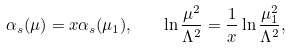Convert formula to latex. <formula><loc_0><loc_0><loc_500><loc_500>\alpha _ { s } ( \mu ) = x \alpha _ { s } ( \mu _ { 1 } ) , \quad \ln \frac { \mu ^ { 2 } } { \Lambda ^ { 2 } } = \frac { 1 } { x } \ln \frac { \mu _ { 1 } ^ { 2 } } { \Lambda ^ { 2 } } ,</formula> 